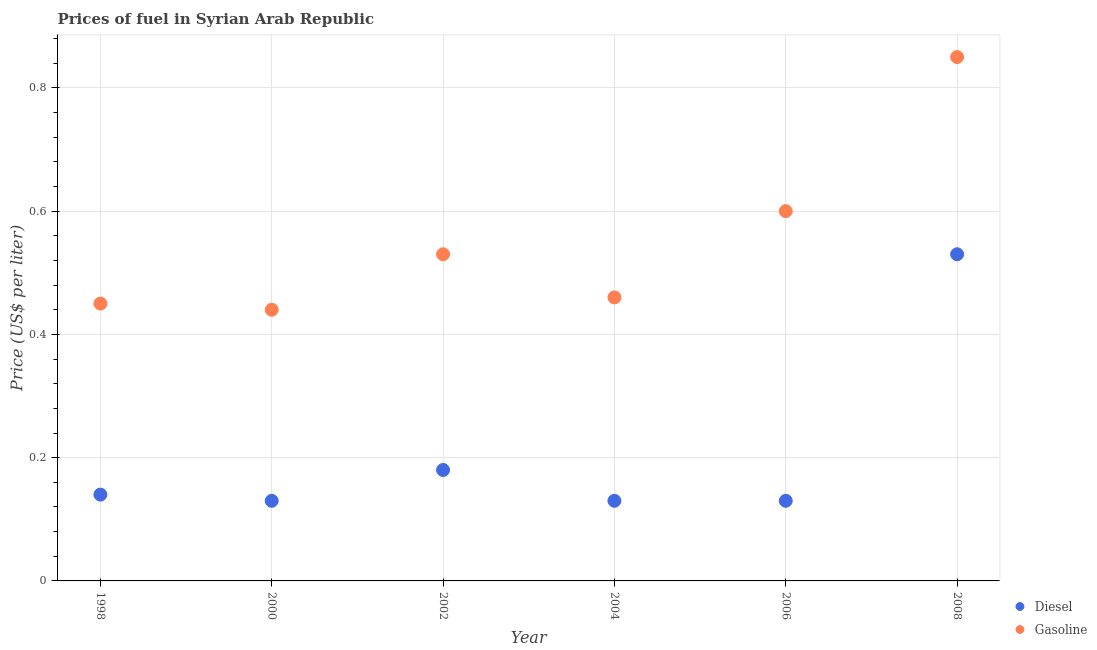What is the gasoline price in 2000?
Give a very brief answer. 0.44. Across all years, what is the maximum diesel price?
Make the answer very short. 0.53. Across all years, what is the minimum gasoline price?
Offer a very short reply. 0.44. In which year was the gasoline price maximum?
Your answer should be compact. 2008. What is the total gasoline price in the graph?
Provide a short and direct response. 3.33. What is the difference between the gasoline price in 2002 and that in 2006?
Give a very brief answer. -0.07. What is the difference between the gasoline price in 2004 and the diesel price in 2008?
Provide a succinct answer. -0.07. What is the average diesel price per year?
Make the answer very short. 0.21. In the year 2002, what is the difference between the diesel price and gasoline price?
Offer a very short reply. -0.35. What is the ratio of the gasoline price in 1998 to that in 2008?
Keep it short and to the point. 0.53. Is the gasoline price in 1998 less than that in 2006?
Offer a very short reply. Yes. Is the difference between the gasoline price in 2000 and 2002 greater than the difference between the diesel price in 2000 and 2002?
Make the answer very short. No. What is the difference between the highest and the second highest diesel price?
Make the answer very short. 0.35. What is the difference between the highest and the lowest gasoline price?
Keep it short and to the point. 0.41. Does the gasoline price monotonically increase over the years?
Keep it short and to the point. No. How many years are there in the graph?
Provide a short and direct response. 6. Are the values on the major ticks of Y-axis written in scientific E-notation?
Give a very brief answer. No. Does the graph contain any zero values?
Your response must be concise. No. Where does the legend appear in the graph?
Your answer should be very brief. Bottom right. How many legend labels are there?
Keep it short and to the point. 2. What is the title of the graph?
Offer a terse response. Prices of fuel in Syrian Arab Republic. Does "Under five" appear as one of the legend labels in the graph?
Make the answer very short. No. What is the label or title of the Y-axis?
Provide a succinct answer. Price (US$ per liter). What is the Price (US$ per liter) in Diesel in 1998?
Make the answer very short. 0.14. What is the Price (US$ per liter) in Gasoline in 1998?
Provide a short and direct response. 0.45. What is the Price (US$ per liter) in Diesel in 2000?
Ensure brevity in your answer.  0.13. What is the Price (US$ per liter) of Gasoline in 2000?
Provide a short and direct response. 0.44. What is the Price (US$ per liter) of Diesel in 2002?
Provide a succinct answer. 0.18. What is the Price (US$ per liter) of Gasoline in 2002?
Ensure brevity in your answer.  0.53. What is the Price (US$ per liter) of Diesel in 2004?
Offer a very short reply. 0.13. What is the Price (US$ per liter) in Gasoline in 2004?
Make the answer very short. 0.46. What is the Price (US$ per liter) of Diesel in 2006?
Your answer should be compact. 0.13. What is the Price (US$ per liter) in Diesel in 2008?
Your response must be concise. 0.53. Across all years, what is the maximum Price (US$ per liter) in Diesel?
Your answer should be very brief. 0.53. Across all years, what is the minimum Price (US$ per liter) in Diesel?
Offer a very short reply. 0.13. Across all years, what is the minimum Price (US$ per liter) of Gasoline?
Keep it short and to the point. 0.44. What is the total Price (US$ per liter) in Diesel in the graph?
Your answer should be very brief. 1.24. What is the total Price (US$ per liter) in Gasoline in the graph?
Make the answer very short. 3.33. What is the difference between the Price (US$ per liter) in Diesel in 1998 and that in 2000?
Make the answer very short. 0.01. What is the difference between the Price (US$ per liter) in Gasoline in 1998 and that in 2000?
Your answer should be compact. 0.01. What is the difference between the Price (US$ per liter) in Diesel in 1998 and that in 2002?
Offer a very short reply. -0.04. What is the difference between the Price (US$ per liter) of Gasoline in 1998 and that in 2002?
Give a very brief answer. -0.08. What is the difference between the Price (US$ per liter) in Diesel in 1998 and that in 2004?
Keep it short and to the point. 0.01. What is the difference between the Price (US$ per liter) in Gasoline in 1998 and that in 2004?
Your answer should be compact. -0.01. What is the difference between the Price (US$ per liter) in Diesel in 1998 and that in 2006?
Keep it short and to the point. 0.01. What is the difference between the Price (US$ per liter) of Gasoline in 1998 and that in 2006?
Provide a succinct answer. -0.15. What is the difference between the Price (US$ per liter) in Diesel in 1998 and that in 2008?
Provide a short and direct response. -0.39. What is the difference between the Price (US$ per liter) in Gasoline in 2000 and that in 2002?
Your answer should be very brief. -0.09. What is the difference between the Price (US$ per liter) in Gasoline in 2000 and that in 2004?
Your response must be concise. -0.02. What is the difference between the Price (US$ per liter) of Gasoline in 2000 and that in 2006?
Keep it short and to the point. -0.16. What is the difference between the Price (US$ per liter) of Diesel in 2000 and that in 2008?
Provide a succinct answer. -0.4. What is the difference between the Price (US$ per liter) in Gasoline in 2000 and that in 2008?
Your answer should be very brief. -0.41. What is the difference between the Price (US$ per liter) of Diesel in 2002 and that in 2004?
Your answer should be compact. 0.05. What is the difference between the Price (US$ per liter) of Gasoline in 2002 and that in 2004?
Give a very brief answer. 0.07. What is the difference between the Price (US$ per liter) in Diesel in 2002 and that in 2006?
Your answer should be very brief. 0.05. What is the difference between the Price (US$ per liter) in Gasoline in 2002 and that in 2006?
Make the answer very short. -0.07. What is the difference between the Price (US$ per liter) in Diesel in 2002 and that in 2008?
Keep it short and to the point. -0.35. What is the difference between the Price (US$ per liter) of Gasoline in 2002 and that in 2008?
Offer a terse response. -0.32. What is the difference between the Price (US$ per liter) in Gasoline in 2004 and that in 2006?
Your answer should be compact. -0.14. What is the difference between the Price (US$ per liter) in Gasoline in 2004 and that in 2008?
Make the answer very short. -0.39. What is the difference between the Price (US$ per liter) in Gasoline in 2006 and that in 2008?
Make the answer very short. -0.25. What is the difference between the Price (US$ per liter) of Diesel in 1998 and the Price (US$ per liter) of Gasoline in 2002?
Provide a succinct answer. -0.39. What is the difference between the Price (US$ per liter) of Diesel in 1998 and the Price (US$ per liter) of Gasoline in 2004?
Ensure brevity in your answer.  -0.32. What is the difference between the Price (US$ per liter) in Diesel in 1998 and the Price (US$ per liter) in Gasoline in 2006?
Keep it short and to the point. -0.46. What is the difference between the Price (US$ per liter) in Diesel in 1998 and the Price (US$ per liter) in Gasoline in 2008?
Provide a succinct answer. -0.71. What is the difference between the Price (US$ per liter) in Diesel in 2000 and the Price (US$ per liter) in Gasoline in 2002?
Your answer should be compact. -0.4. What is the difference between the Price (US$ per liter) of Diesel in 2000 and the Price (US$ per liter) of Gasoline in 2004?
Keep it short and to the point. -0.33. What is the difference between the Price (US$ per liter) in Diesel in 2000 and the Price (US$ per liter) in Gasoline in 2006?
Give a very brief answer. -0.47. What is the difference between the Price (US$ per liter) of Diesel in 2000 and the Price (US$ per liter) of Gasoline in 2008?
Keep it short and to the point. -0.72. What is the difference between the Price (US$ per liter) in Diesel in 2002 and the Price (US$ per liter) in Gasoline in 2004?
Your answer should be compact. -0.28. What is the difference between the Price (US$ per liter) of Diesel in 2002 and the Price (US$ per liter) of Gasoline in 2006?
Offer a very short reply. -0.42. What is the difference between the Price (US$ per liter) of Diesel in 2002 and the Price (US$ per liter) of Gasoline in 2008?
Provide a succinct answer. -0.67. What is the difference between the Price (US$ per liter) of Diesel in 2004 and the Price (US$ per liter) of Gasoline in 2006?
Make the answer very short. -0.47. What is the difference between the Price (US$ per liter) in Diesel in 2004 and the Price (US$ per liter) in Gasoline in 2008?
Give a very brief answer. -0.72. What is the difference between the Price (US$ per liter) in Diesel in 2006 and the Price (US$ per liter) in Gasoline in 2008?
Ensure brevity in your answer.  -0.72. What is the average Price (US$ per liter) of Diesel per year?
Provide a short and direct response. 0.21. What is the average Price (US$ per liter) in Gasoline per year?
Ensure brevity in your answer.  0.56. In the year 1998, what is the difference between the Price (US$ per liter) in Diesel and Price (US$ per liter) in Gasoline?
Ensure brevity in your answer.  -0.31. In the year 2000, what is the difference between the Price (US$ per liter) in Diesel and Price (US$ per liter) in Gasoline?
Ensure brevity in your answer.  -0.31. In the year 2002, what is the difference between the Price (US$ per liter) of Diesel and Price (US$ per liter) of Gasoline?
Offer a very short reply. -0.35. In the year 2004, what is the difference between the Price (US$ per liter) of Diesel and Price (US$ per liter) of Gasoline?
Your answer should be compact. -0.33. In the year 2006, what is the difference between the Price (US$ per liter) of Diesel and Price (US$ per liter) of Gasoline?
Make the answer very short. -0.47. In the year 2008, what is the difference between the Price (US$ per liter) in Diesel and Price (US$ per liter) in Gasoline?
Ensure brevity in your answer.  -0.32. What is the ratio of the Price (US$ per liter) of Gasoline in 1998 to that in 2000?
Your answer should be very brief. 1.02. What is the ratio of the Price (US$ per liter) of Diesel in 1998 to that in 2002?
Your answer should be very brief. 0.78. What is the ratio of the Price (US$ per liter) in Gasoline in 1998 to that in 2002?
Provide a short and direct response. 0.85. What is the ratio of the Price (US$ per liter) of Gasoline in 1998 to that in 2004?
Keep it short and to the point. 0.98. What is the ratio of the Price (US$ per liter) of Diesel in 1998 to that in 2008?
Ensure brevity in your answer.  0.26. What is the ratio of the Price (US$ per liter) of Gasoline in 1998 to that in 2008?
Your response must be concise. 0.53. What is the ratio of the Price (US$ per liter) of Diesel in 2000 to that in 2002?
Your response must be concise. 0.72. What is the ratio of the Price (US$ per liter) in Gasoline in 2000 to that in 2002?
Ensure brevity in your answer.  0.83. What is the ratio of the Price (US$ per liter) in Diesel in 2000 to that in 2004?
Provide a succinct answer. 1. What is the ratio of the Price (US$ per liter) in Gasoline in 2000 to that in 2004?
Ensure brevity in your answer.  0.96. What is the ratio of the Price (US$ per liter) in Diesel in 2000 to that in 2006?
Offer a very short reply. 1. What is the ratio of the Price (US$ per liter) in Gasoline in 2000 to that in 2006?
Provide a succinct answer. 0.73. What is the ratio of the Price (US$ per liter) of Diesel in 2000 to that in 2008?
Keep it short and to the point. 0.25. What is the ratio of the Price (US$ per liter) in Gasoline in 2000 to that in 2008?
Your answer should be very brief. 0.52. What is the ratio of the Price (US$ per liter) of Diesel in 2002 to that in 2004?
Your answer should be very brief. 1.38. What is the ratio of the Price (US$ per liter) of Gasoline in 2002 to that in 2004?
Your answer should be compact. 1.15. What is the ratio of the Price (US$ per liter) in Diesel in 2002 to that in 2006?
Your answer should be very brief. 1.38. What is the ratio of the Price (US$ per liter) of Gasoline in 2002 to that in 2006?
Provide a short and direct response. 0.88. What is the ratio of the Price (US$ per liter) of Diesel in 2002 to that in 2008?
Offer a very short reply. 0.34. What is the ratio of the Price (US$ per liter) in Gasoline in 2002 to that in 2008?
Make the answer very short. 0.62. What is the ratio of the Price (US$ per liter) of Gasoline in 2004 to that in 2006?
Ensure brevity in your answer.  0.77. What is the ratio of the Price (US$ per liter) in Diesel in 2004 to that in 2008?
Ensure brevity in your answer.  0.25. What is the ratio of the Price (US$ per liter) in Gasoline in 2004 to that in 2008?
Keep it short and to the point. 0.54. What is the ratio of the Price (US$ per liter) of Diesel in 2006 to that in 2008?
Your response must be concise. 0.25. What is the ratio of the Price (US$ per liter) of Gasoline in 2006 to that in 2008?
Your answer should be compact. 0.71. What is the difference between the highest and the second highest Price (US$ per liter) in Diesel?
Make the answer very short. 0.35. What is the difference between the highest and the lowest Price (US$ per liter) of Gasoline?
Keep it short and to the point. 0.41. 